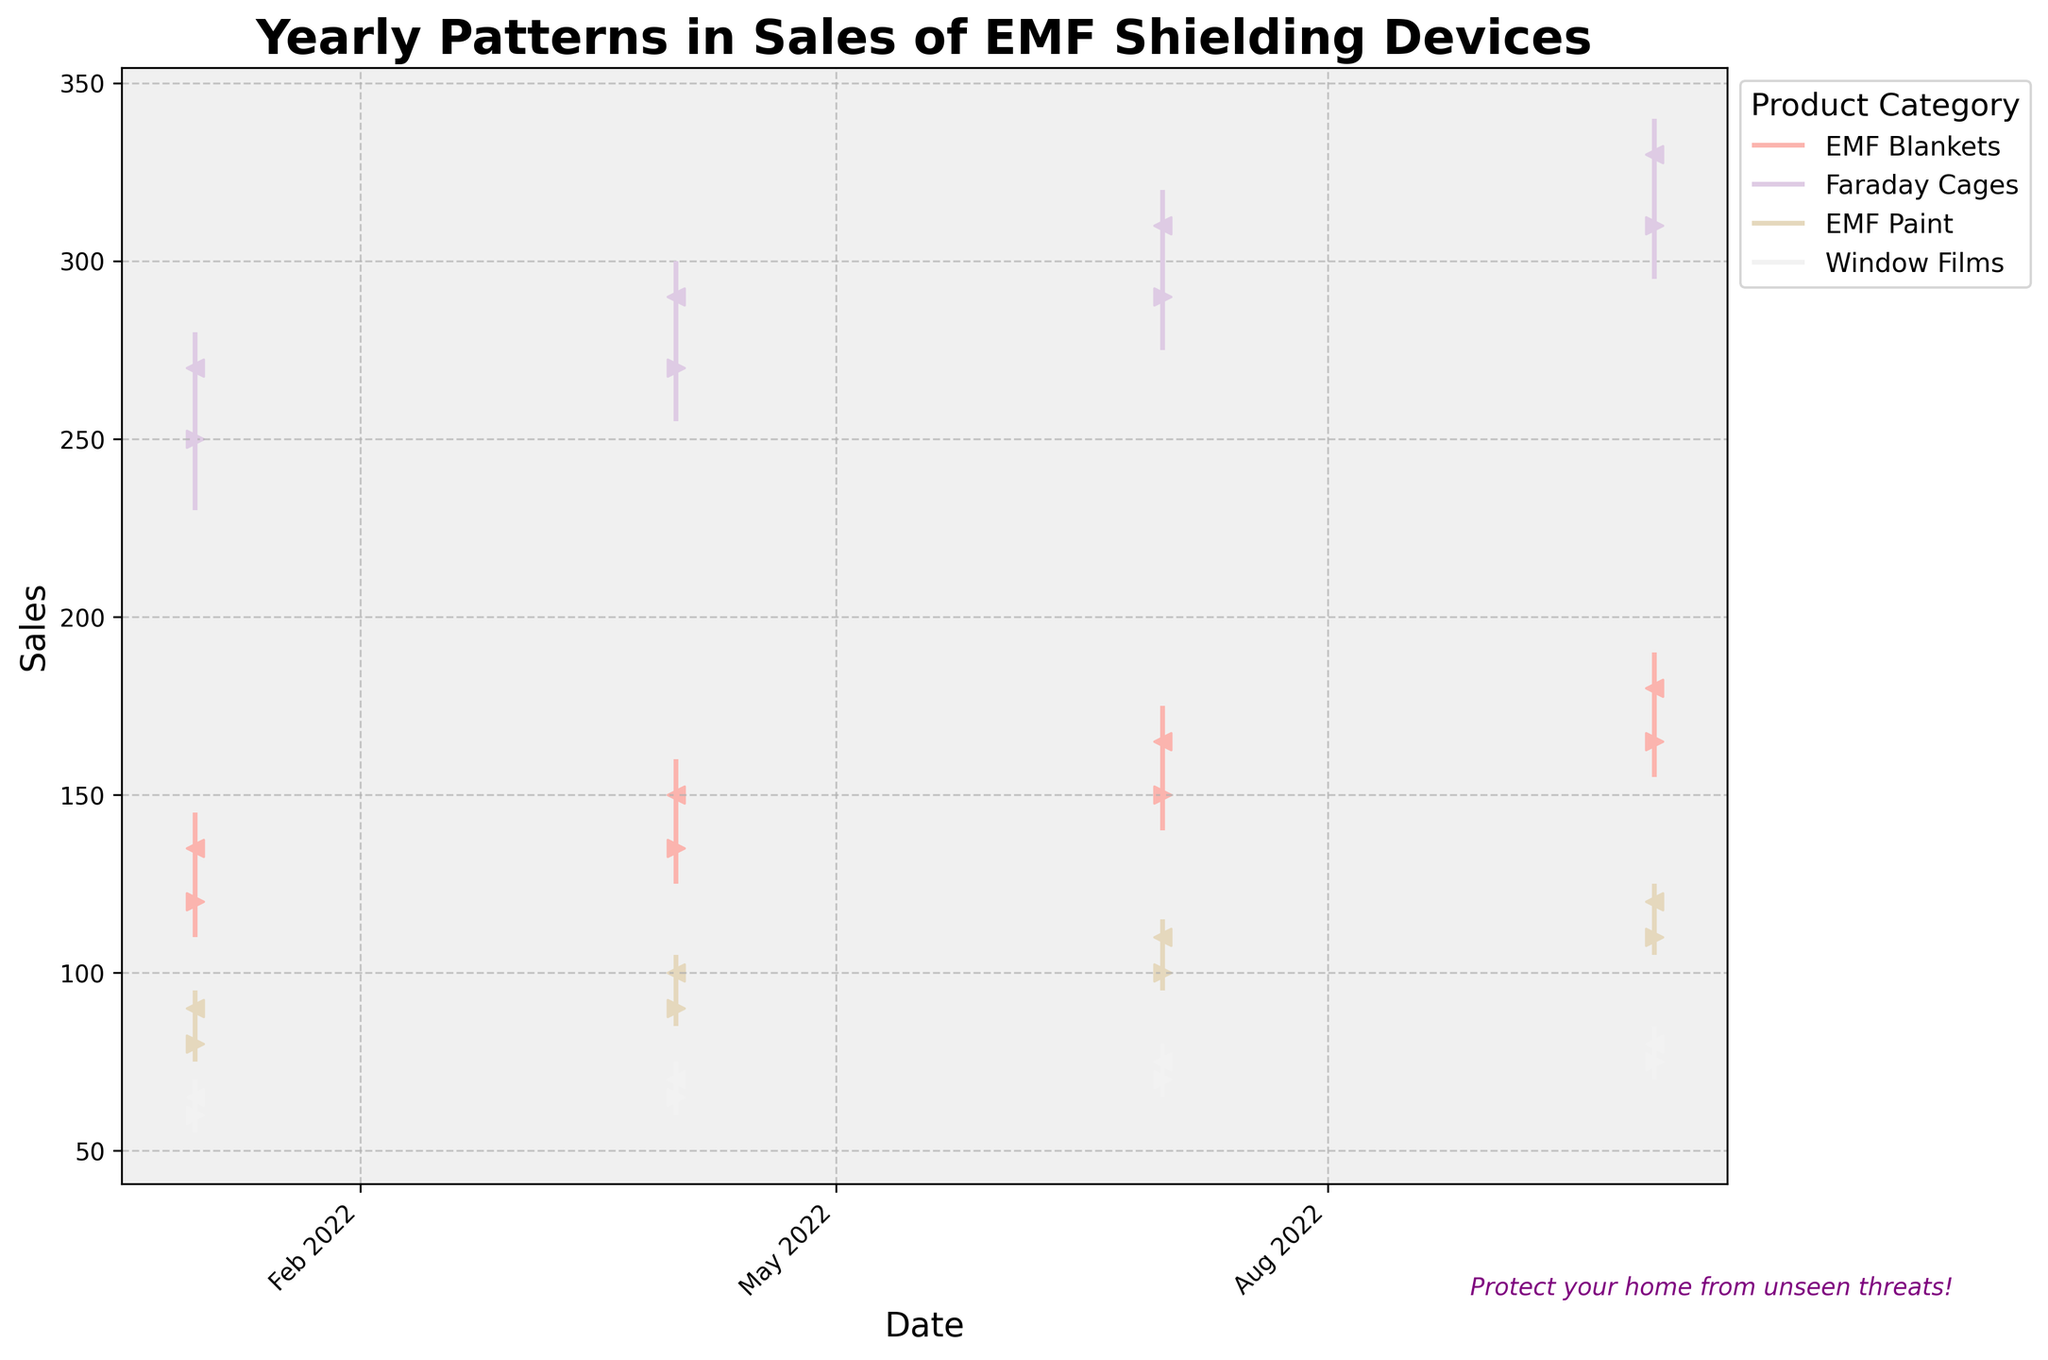How many different product categories are shown in the figure? Count the unique labels in the legend.
Answer: 4 Which product category had the highest closing sales price in October 2022? Find the category with the highest "Close" value in October 2022.
Answer: Faraday Cages What pattern do you notice in the sales of EMF Blankets throughout the year? Look at the trend over each quarter for EMF Blankets and describe the changes from one point to the next.
Answer: Increasing Compare the sales high and low of Faraday Cages in January 2022 and July 2022. Which month had a larger sales range? Calculate the difference between high and low for both months and compare the values. January: (280 - 230) = 50, July: (320 - 275) = 45
Answer: January What was the overall trend in the sales of Window Films from January to October 2022? Review the sales values (Open, High, Low, Close) for Window Films across the three displayed months.
Answer: Increasing On which date did EMF Paint reach its highest sales price of the year? Identify the month and year in which the "High" value for EMF Paint is the maximum.
Answer: October 2022 Which product category showed the most consistent growth in closing sales prices throughout the year 2022? Compare the incremental changes in closing prices for each category across all quarters.
Answer: EMF Paint How did the lowest sales price for Window Films in July 2022 compare to the opening sales price in January 2022? Identify the “Low” value for Window Films in July and the “Open” value in January, and compare them. July Low: 65, January Open: 60
Answer: Higher What is the difference between the opening sales price of EMF Blankets in January 2022 and the closing sales price in October 2022? Subtract the January 2022 "Open" price from the October 2022 "Close" price for EMF Blankets. October Close: 180, January Open: 120. So, 180 - 120 = 60
Answer: 60 